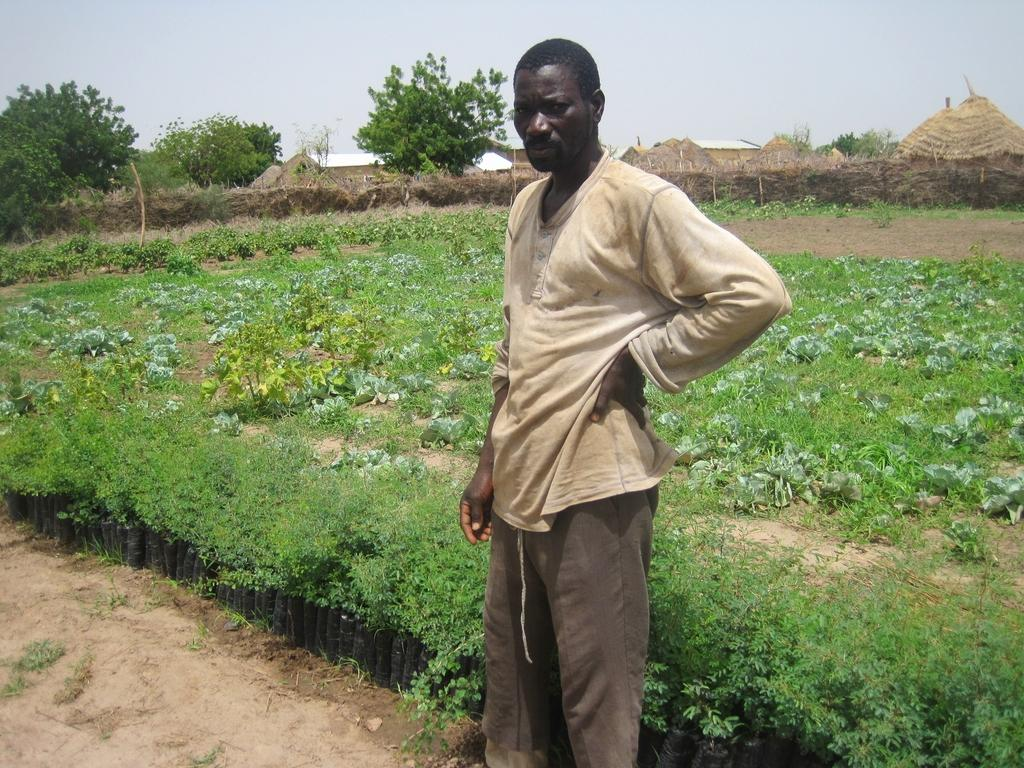What is the person in the image wearing? The person in the image is wearing a white t-shirt. What is the person's position in relation to the ground? The person is standing on the ground. What can be seen near the person in the image? The person is near plants. What is visible in the background of the image? There is a field, shelters, trees, and the sky visible in the background of the image. What type of crown is the person wearing in the image? There is no crown visible in the image; the person is wearing a white t-shirt. What type of camera is the person using to capture the scene in the image? There is no camera visible in the image; the person is not depicted as taking a photo. 